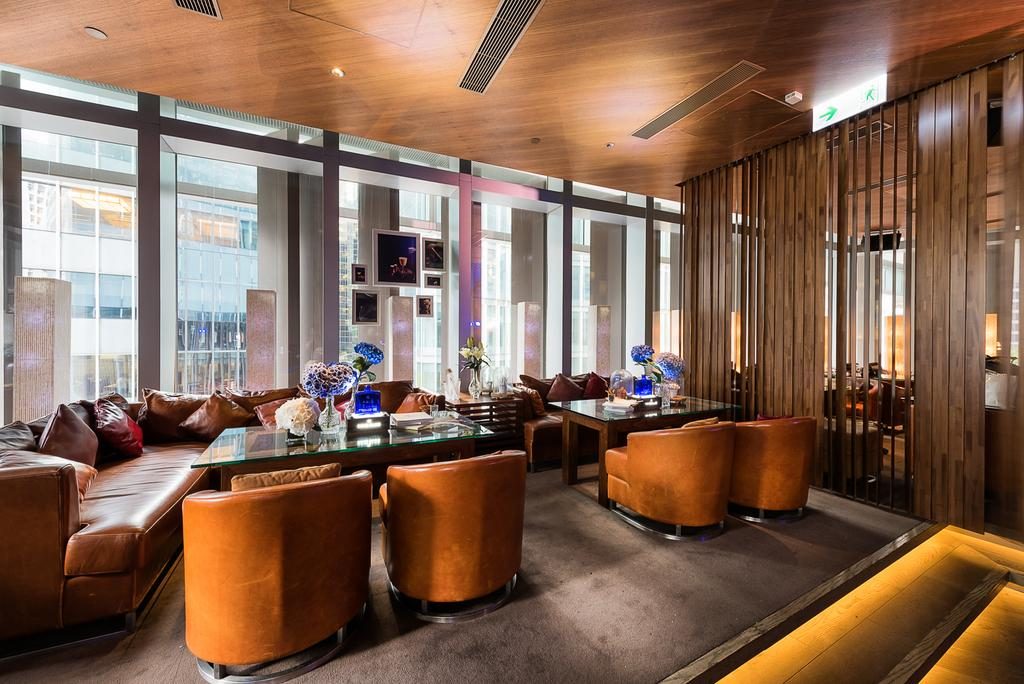What type of furniture is visible in the image? There are sofas and tables in the image. What can be found on the tables in the image? Flower vases are present on the tables. Are there any decorative items on the walls in the image? Yes, there are frames on the wall. What type of prose is being recited by the dad in the image? There is no dad or prose present in the image; it only features sofas, tables, flower vases, and frames on the wall. 